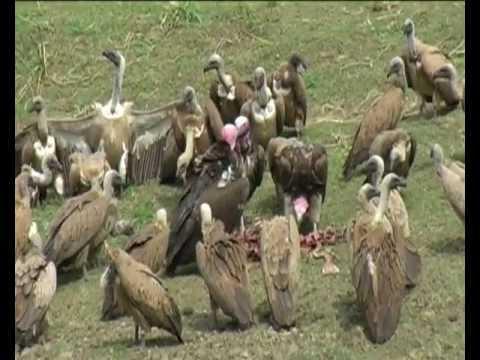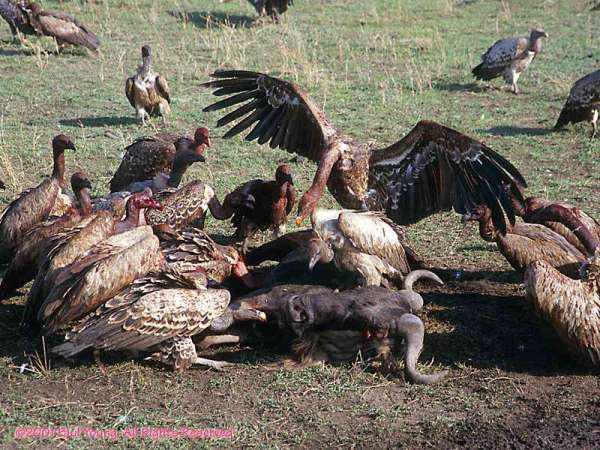The first image is the image on the left, the second image is the image on the right. Considering the images on both sides, is "The carrion being eaten by the birds in the image on the left can be clearly seen." valid? Answer yes or no. Yes. 